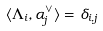<formula> <loc_0><loc_0><loc_500><loc_500>\langle \Lambda _ { i } , \alpha ^ { \vee } _ { j } \rangle = \delta _ { i , j }</formula> 